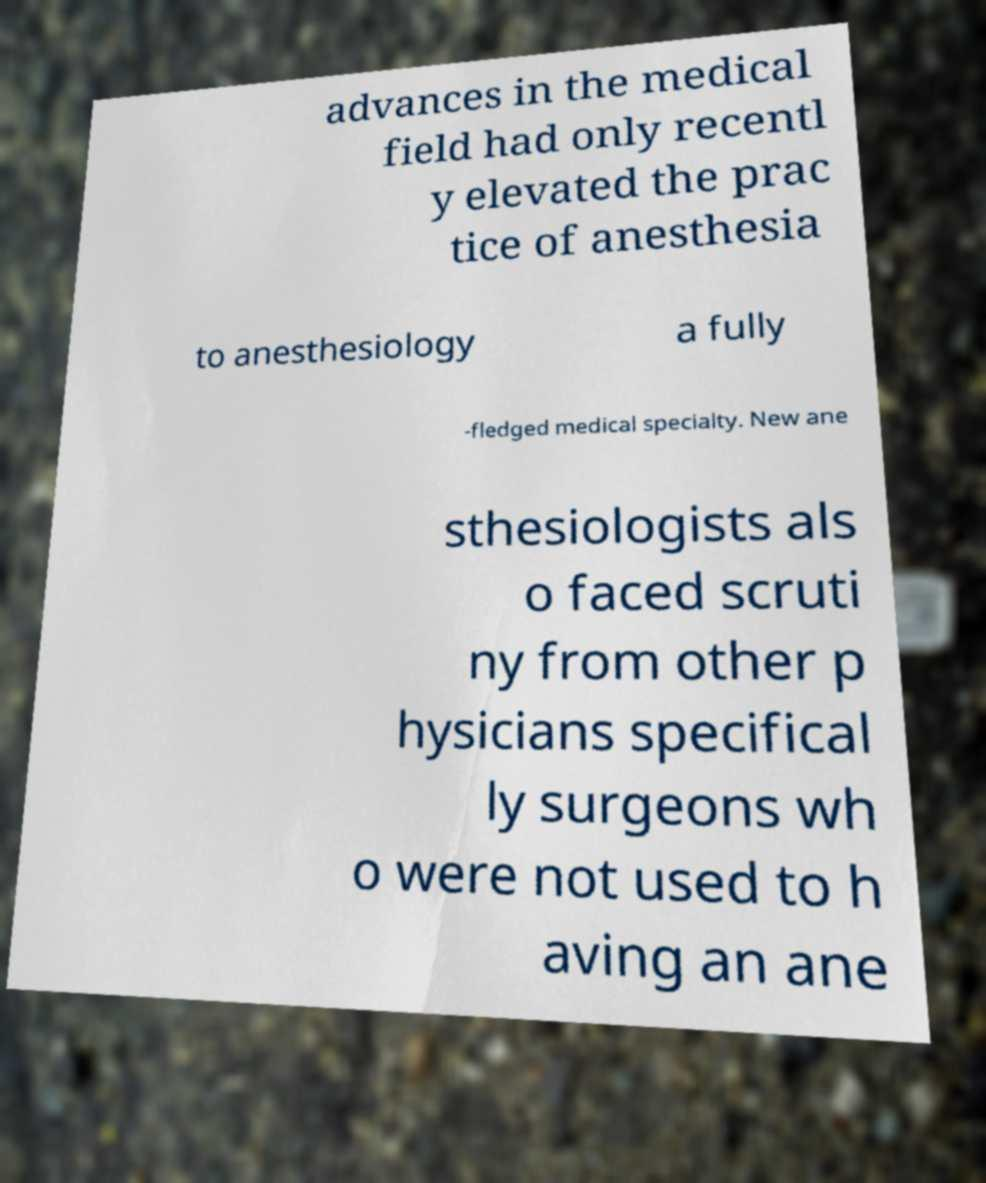There's text embedded in this image that I need extracted. Can you transcribe it verbatim? advances in the medical field had only recentl y elevated the prac tice of anesthesia to anesthesiology a fully -fledged medical specialty. New ane sthesiologists als o faced scruti ny from other p hysicians specifical ly surgeons wh o were not used to h aving an ane 